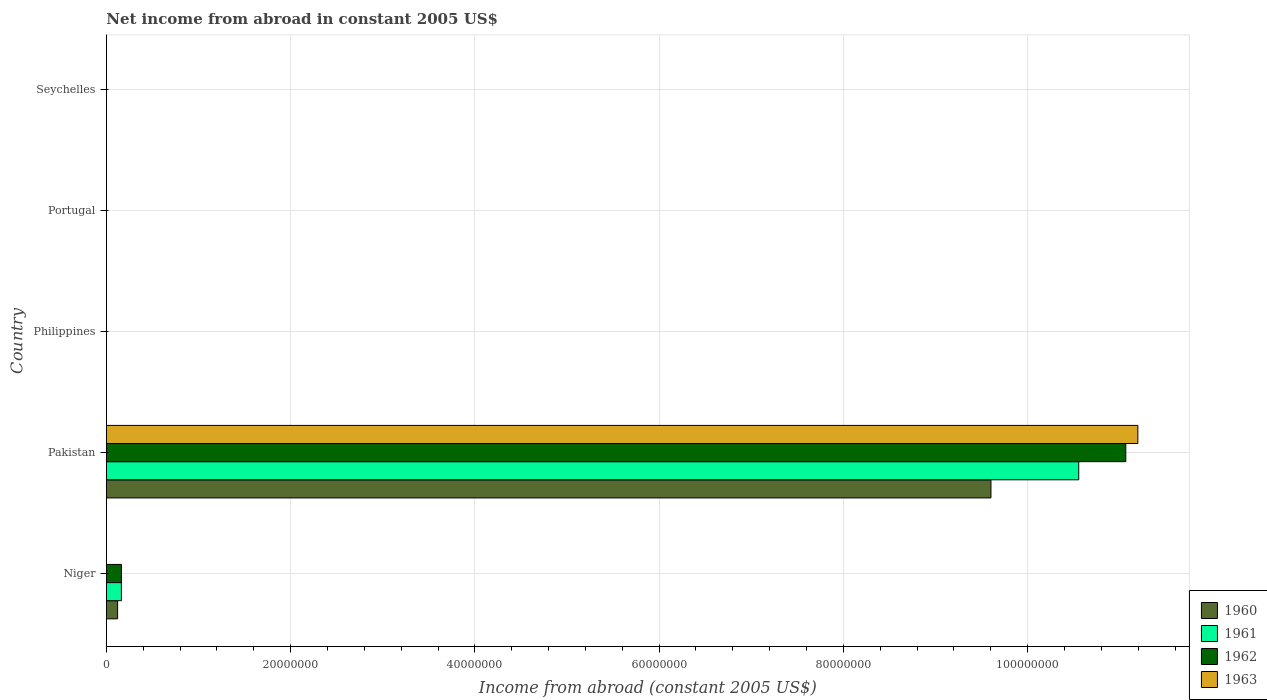Are the number of bars per tick equal to the number of legend labels?
Provide a short and direct response. No. How many bars are there on the 5th tick from the top?
Offer a terse response. 3. How many bars are there on the 3rd tick from the bottom?
Ensure brevity in your answer.  0. What is the label of the 4th group of bars from the top?
Give a very brief answer. Pakistan. In how many cases, is the number of bars for a given country not equal to the number of legend labels?
Give a very brief answer. 4. What is the net income from abroad in 1962 in Philippines?
Keep it short and to the point. 0. Across all countries, what is the maximum net income from abroad in 1960?
Your answer should be very brief. 9.60e+07. Across all countries, what is the minimum net income from abroad in 1962?
Offer a terse response. 0. What is the total net income from abroad in 1963 in the graph?
Your answer should be very brief. 1.12e+08. What is the difference between the net income from abroad in 1960 in Niger and that in Pakistan?
Provide a succinct answer. -9.48e+07. What is the average net income from abroad in 1960 per country?
Offer a very short reply. 1.94e+07. What is the difference between the net income from abroad in 1963 and net income from abroad in 1962 in Pakistan?
Offer a terse response. 1.31e+06. In how many countries, is the net income from abroad in 1961 greater than 92000000 US$?
Provide a short and direct response. 1. What is the difference between the highest and the lowest net income from abroad in 1961?
Offer a terse response. 1.06e+08. How many bars are there?
Provide a succinct answer. 7. Are all the bars in the graph horizontal?
Provide a succinct answer. Yes. Are the values on the major ticks of X-axis written in scientific E-notation?
Offer a very short reply. No. Does the graph contain any zero values?
Offer a terse response. Yes. Where does the legend appear in the graph?
Your answer should be compact. Bottom right. How many legend labels are there?
Your answer should be very brief. 4. What is the title of the graph?
Offer a terse response. Net income from abroad in constant 2005 US$. Does "1996" appear as one of the legend labels in the graph?
Ensure brevity in your answer.  No. What is the label or title of the X-axis?
Your answer should be very brief. Income from abroad (constant 2005 US$). What is the label or title of the Y-axis?
Offer a terse response. Country. What is the Income from abroad (constant 2005 US$) in 1960 in Niger?
Your response must be concise. 1.22e+06. What is the Income from abroad (constant 2005 US$) of 1961 in Niger?
Provide a short and direct response. 1.63e+06. What is the Income from abroad (constant 2005 US$) of 1962 in Niger?
Offer a terse response. 1.64e+06. What is the Income from abroad (constant 2005 US$) in 1960 in Pakistan?
Keep it short and to the point. 9.60e+07. What is the Income from abroad (constant 2005 US$) in 1961 in Pakistan?
Your response must be concise. 1.06e+08. What is the Income from abroad (constant 2005 US$) of 1962 in Pakistan?
Offer a terse response. 1.11e+08. What is the Income from abroad (constant 2005 US$) of 1963 in Pakistan?
Make the answer very short. 1.12e+08. What is the Income from abroad (constant 2005 US$) of 1960 in Philippines?
Offer a very short reply. 0. What is the Income from abroad (constant 2005 US$) of 1963 in Philippines?
Offer a terse response. 0. What is the Income from abroad (constant 2005 US$) of 1960 in Portugal?
Provide a succinct answer. 0. What is the Income from abroad (constant 2005 US$) in 1961 in Seychelles?
Your response must be concise. 0. What is the Income from abroad (constant 2005 US$) of 1963 in Seychelles?
Provide a succinct answer. 0. Across all countries, what is the maximum Income from abroad (constant 2005 US$) of 1960?
Give a very brief answer. 9.60e+07. Across all countries, what is the maximum Income from abroad (constant 2005 US$) of 1961?
Ensure brevity in your answer.  1.06e+08. Across all countries, what is the maximum Income from abroad (constant 2005 US$) of 1962?
Make the answer very short. 1.11e+08. Across all countries, what is the maximum Income from abroad (constant 2005 US$) in 1963?
Provide a succinct answer. 1.12e+08. Across all countries, what is the minimum Income from abroad (constant 2005 US$) in 1962?
Offer a very short reply. 0. Across all countries, what is the minimum Income from abroad (constant 2005 US$) in 1963?
Provide a succinct answer. 0. What is the total Income from abroad (constant 2005 US$) of 1960 in the graph?
Ensure brevity in your answer.  9.72e+07. What is the total Income from abroad (constant 2005 US$) of 1961 in the graph?
Offer a very short reply. 1.07e+08. What is the total Income from abroad (constant 2005 US$) of 1962 in the graph?
Provide a succinct answer. 1.12e+08. What is the total Income from abroad (constant 2005 US$) of 1963 in the graph?
Offer a very short reply. 1.12e+08. What is the difference between the Income from abroad (constant 2005 US$) in 1960 in Niger and that in Pakistan?
Make the answer very short. -9.48e+07. What is the difference between the Income from abroad (constant 2005 US$) in 1961 in Niger and that in Pakistan?
Ensure brevity in your answer.  -1.04e+08. What is the difference between the Income from abroad (constant 2005 US$) in 1962 in Niger and that in Pakistan?
Make the answer very short. -1.09e+08. What is the difference between the Income from abroad (constant 2005 US$) of 1960 in Niger and the Income from abroad (constant 2005 US$) of 1961 in Pakistan?
Give a very brief answer. -1.04e+08. What is the difference between the Income from abroad (constant 2005 US$) of 1960 in Niger and the Income from abroad (constant 2005 US$) of 1962 in Pakistan?
Offer a terse response. -1.09e+08. What is the difference between the Income from abroad (constant 2005 US$) in 1960 in Niger and the Income from abroad (constant 2005 US$) in 1963 in Pakistan?
Your answer should be compact. -1.11e+08. What is the difference between the Income from abroad (constant 2005 US$) in 1961 in Niger and the Income from abroad (constant 2005 US$) in 1962 in Pakistan?
Keep it short and to the point. -1.09e+08. What is the difference between the Income from abroad (constant 2005 US$) in 1961 in Niger and the Income from abroad (constant 2005 US$) in 1963 in Pakistan?
Make the answer very short. -1.10e+08. What is the difference between the Income from abroad (constant 2005 US$) in 1962 in Niger and the Income from abroad (constant 2005 US$) in 1963 in Pakistan?
Ensure brevity in your answer.  -1.10e+08. What is the average Income from abroad (constant 2005 US$) in 1960 per country?
Your answer should be compact. 1.94e+07. What is the average Income from abroad (constant 2005 US$) of 1961 per country?
Give a very brief answer. 2.14e+07. What is the average Income from abroad (constant 2005 US$) of 1962 per country?
Give a very brief answer. 2.25e+07. What is the average Income from abroad (constant 2005 US$) of 1963 per country?
Your answer should be compact. 2.24e+07. What is the difference between the Income from abroad (constant 2005 US$) in 1960 and Income from abroad (constant 2005 US$) in 1961 in Niger?
Keep it short and to the point. -4.08e+05. What is the difference between the Income from abroad (constant 2005 US$) in 1960 and Income from abroad (constant 2005 US$) in 1962 in Niger?
Make the answer very short. -4.13e+05. What is the difference between the Income from abroad (constant 2005 US$) of 1961 and Income from abroad (constant 2005 US$) of 1962 in Niger?
Your answer should be compact. -5017.31. What is the difference between the Income from abroad (constant 2005 US$) in 1960 and Income from abroad (constant 2005 US$) in 1961 in Pakistan?
Make the answer very short. -9.53e+06. What is the difference between the Income from abroad (constant 2005 US$) of 1960 and Income from abroad (constant 2005 US$) of 1962 in Pakistan?
Make the answer very short. -1.46e+07. What is the difference between the Income from abroad (constant 2005 US$) in 1960 and Income from abroad (constant 2005 US$) in 1963 in Pakistan?
Make the answer very short. -1.59e+07. What is the difference between the Income from abroad (constant 2005 US$) in 1961 and Income from abroad (constant 2005 US$) in 1962 in Pakistan?
Offer a terse response. -5.11e+06. What is the difference between the Income from abroad (constant 2005 US$) in 1961 and Income from abroad (constant 2005 US$) in 1963 in Pakistan?
Your answer should be very brief. -6.42e+06. What is the difference between the Income from abroad (constant 2005 US$) in 1962 and Income from abroad (constant 2005 US$) in 1963 in Pakistan?
Ensure brevity in your answer.  -1.31e+06. What is the ratio of the Income from abroad (constant 2005 US$) in 1960 in Niger to that in Pakistan?
Ensure brevity in your answer.  0.01. What is the ratio of the Income from abroad (constant 2005 US$) in 1961 in Niger to that in Pakistan?
Keep it short and to the point. 0.02. What is the ratio of the Income from abroad (constant 2005 US$) of 1962 in Niger to that in Pakistan?
Ensure brevity in your answer.  0.01. What is the difference between the highest and the lowest Income from abroad (constant 2005 US$) of 1960?
Ensure brevity in your answer.  9.60e+07. What is the difference between the highest and the lowest Income from abroad (constant 2005 US$) of 1961?
Make the answer very short. 1.06e+08. What is the difference between the highest and the lowest Income from abroad (constant 2005 US$) of 1962?
Offer a terse response. 1.11e+08. What is the difference between the highest and the lowest Income from abroad (constant 2005 US$) of 1963?
Ensure brevity in your answer.  1.12e+08. 